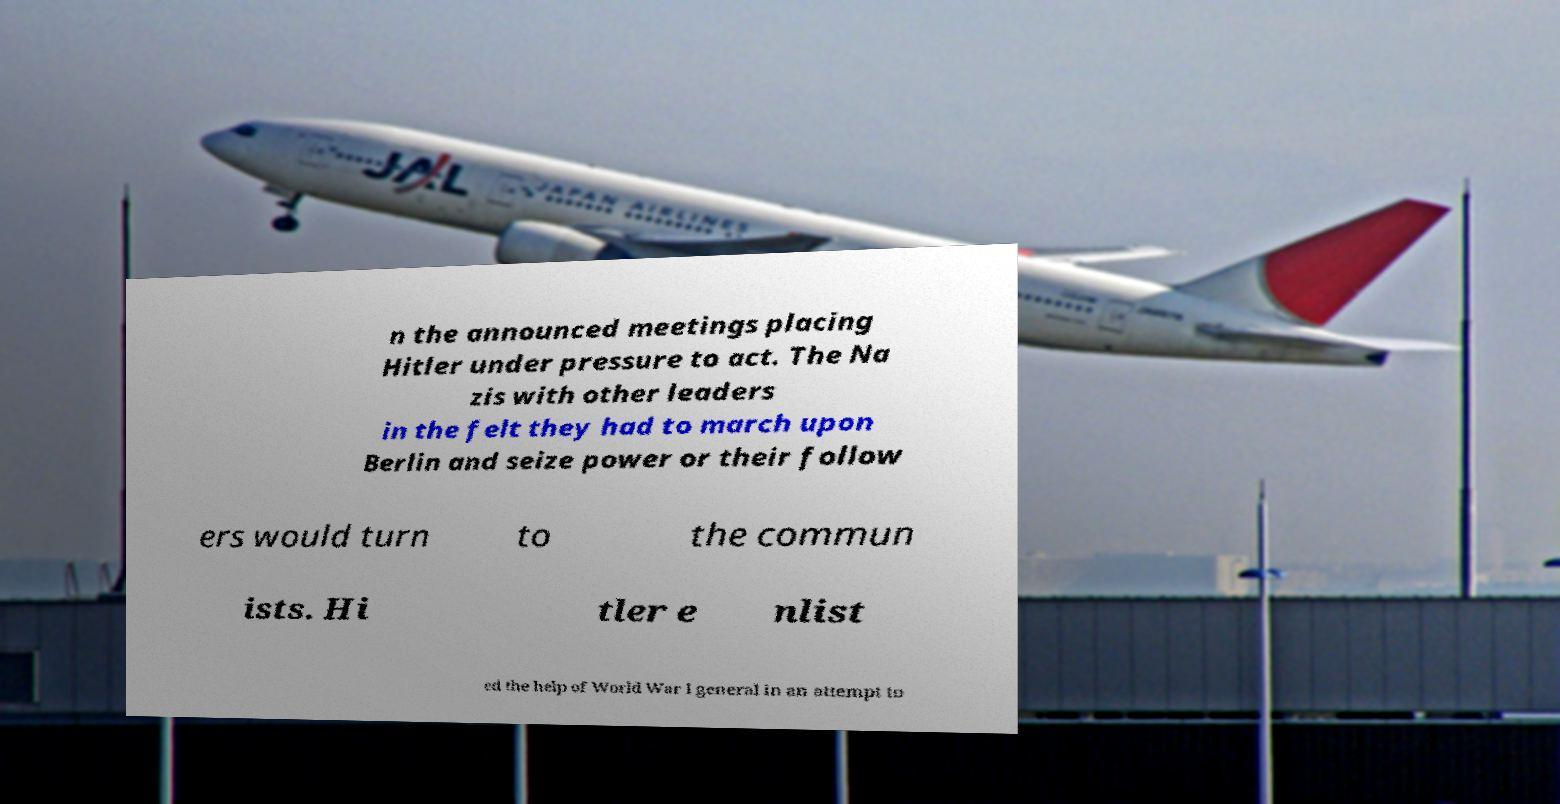Could you extract and type out the text from this image? n the announced meetings placing Hitler under pressure to act. The Na zis with other leaders in the felt they had to march upon Berlin and seize power or their follow ers would turn to the commun ists. Hi tler e nlist ed the help of World War I general in an attempt to 